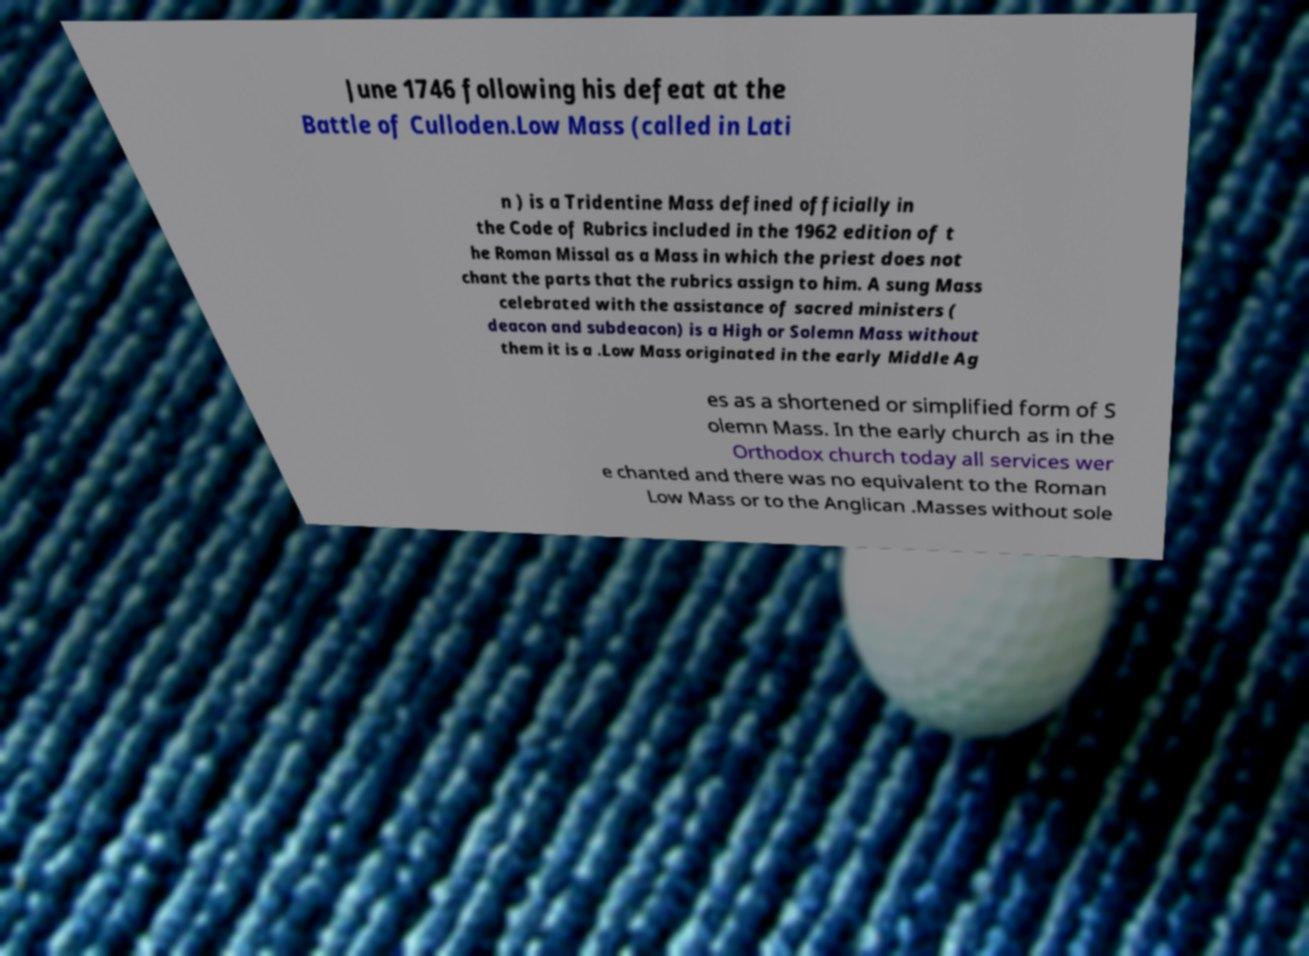For documentation purposes, I need the text within this image transcribed. Could you provide that? June 1746 following his defeat at the Battle of Culloden.Low Mass (called in Lati n ) is a Tridentine Mass defined officially in the Code of Rubrics included in the 1962 edition of t he Roman Missal as a Mass in which the priest does not chant the parts that the rubrics assign to him. A sung Mass celebrated with the assistance of sacred ministers ( deacon and subdeacon) is a High or Solemn Mass without them it is a .Low Mass originated in the early Middle Ag es as a shortened or simplified form of S olemn Mass. In the early church as in the Orthodox church today all services wer e chanted and there was no equivalent to the Roman Low Mass or to the Anglican .Masses without sole 